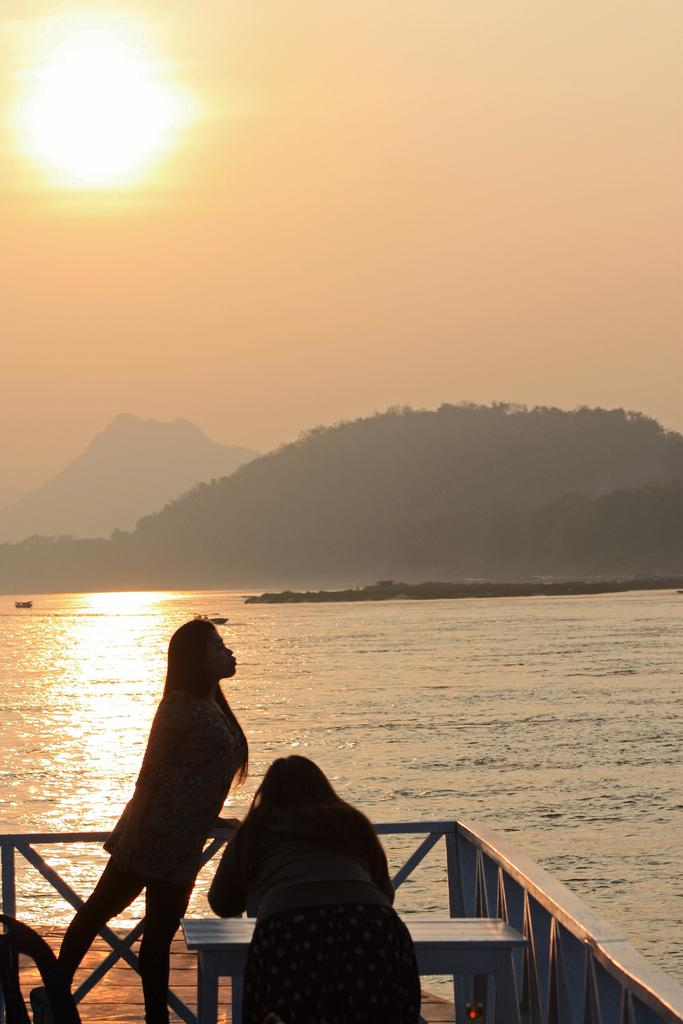How many people are in the image? There are two people in the image. What is the location of the bench in the image? The bench is on a platform in the image. What can be seen in the background of the image? Water, mountains, and the sky are visible in the background of the image. What type of pig can be seen playing with a hose in the image? There is no pig or hose present in the image. What is the weather like in the image? The provided facts do not mention the weather, so we cannot determine the weather from the image. 